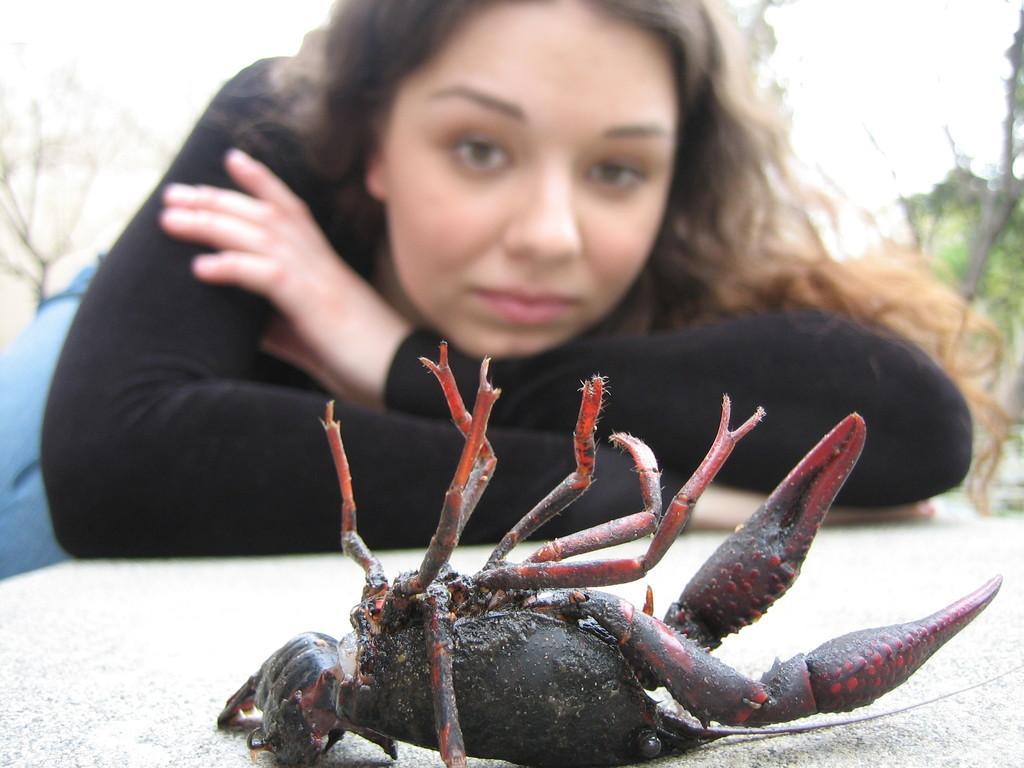Who is the main subject in the image? There is a woman in the center of the image. What is located in front of the woman? There is an object in front of the woman. What can be seen on the object? There is a crab on the object. Can you describe the background of the image? The background of the image is blurred. What type of sock is the woman wearing in the image? There is no sock visible in the image; the focus is on the woman, the object in front of her, and the crab on it. 